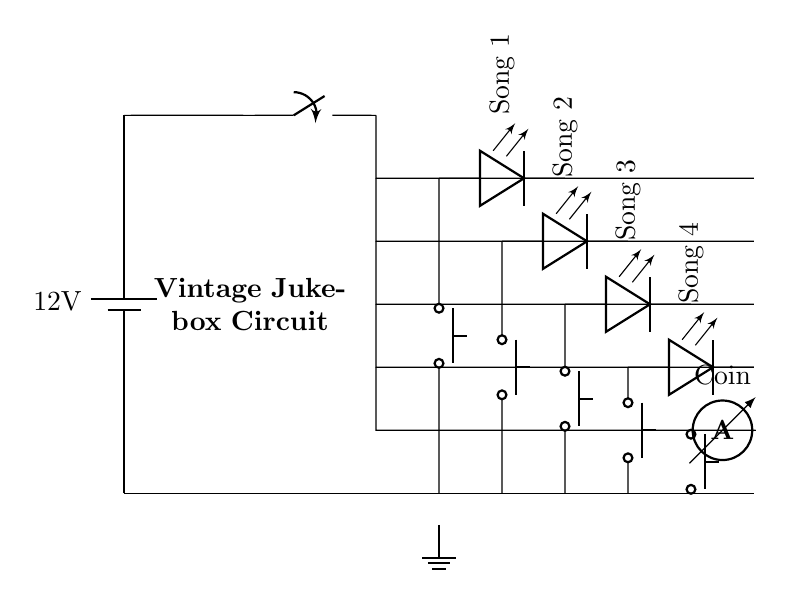What is the main voltage supplied to this circuit? The circuit is powered by a battery labeled with a voltage of 12 volts (V) indicated in the diagram.
Answer: 12 volts How many selection buttons does this jukebox have? There are four selection buttons shown in the diagram, each connected to a different LED representing a song.
Answer: Four What happens when a selection button is pressed? When a selection button is pressed, it completes the circuit for the corresponding LED, lighting it up and indicating the song selection.
Answer: The corresponding LED lights up What is the purpose of the coin mechanism in the circuit? The coin mechanism serves as a switch (push button) that likely activates the system, allowing it to proceed with the jukebox operation or song selection upon detecting a coin.
Answer: Activate the jukebox Which components are used to indicate the selected songs? The selected songs are indicated by four LEDs, each labeled with a song title adjacent to their respective selection buttons in the circuit.
Answer: LEDs In a parallel circuit like this one, how does pressing one button affect the other branches? Pressing one button only closes the circuit for its branch, leaving other branches intact due to the nature of parallel circuits where each branch operates independently.
Answer: Other branches remain unchanged What is the function of the ammeter in this circuit? The ammeter is used to measure the current flowing through the circuit when a coin is detected, providing feedback about the operation of the coin mechanism.
Answer: Measure current 